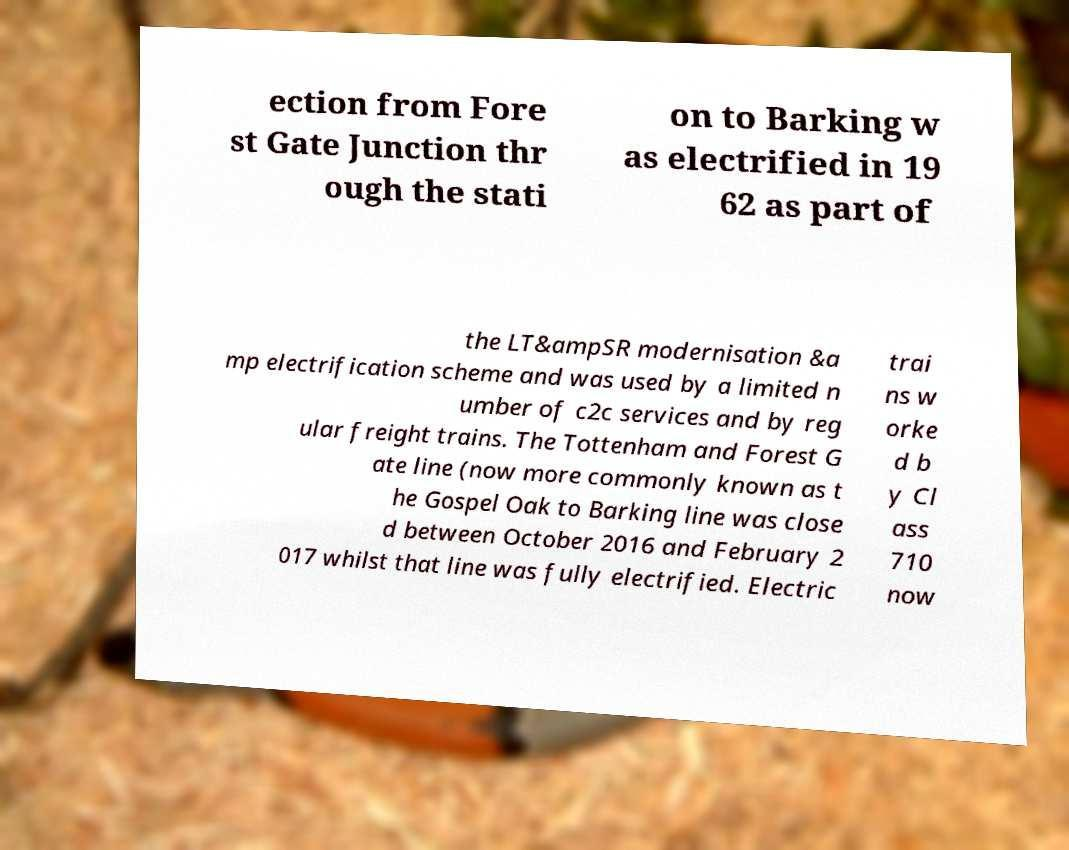Could you assist in decoding the text presented in this image and type it out clearly? ection from Fore st Gate Junction thr ough the stati on to Barking w as electrified in 19 62 as part of the LT&ampSR modernisation &a mp electrification scheme and was used by a limited n umber of c2c services and by reg ular freight trains. The Tottenham and Forest G ate line (now more commonly known as t he Gospel Oak to Barking line was close d between October 2016 and February 2 017 whilst that line was fully electrified. Electric trai ns w orke d b y Cl ass 710 now 